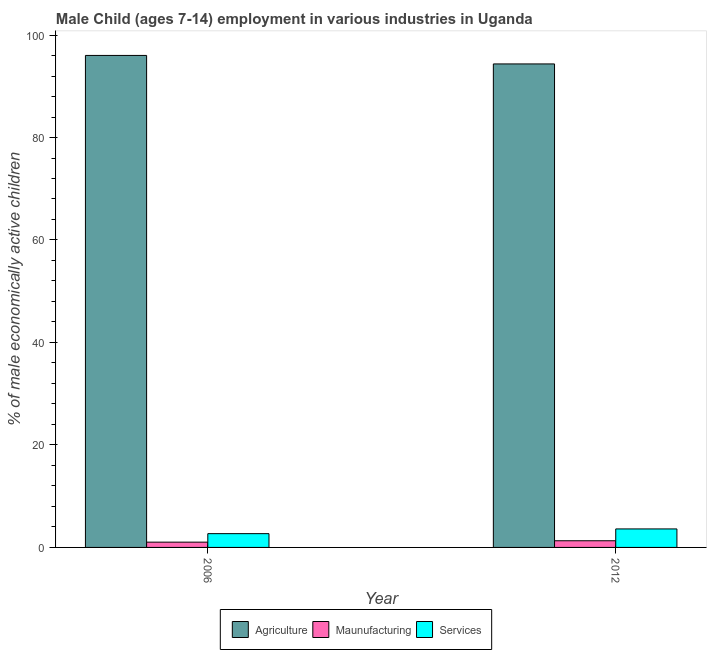How many groups of bars are there?
Offer a very short reply. 2. What is the label of the 1st group of bars from the left?
Provide a short and direct response. 2006. What is the percentage of economically active children in services in 2006?
Provide a succinct answer. 2.69. Across all years, what is the maximum percentage of economically active children in services?
Ensure brevity in your answer.  3.61. In which year was the percentage of economically active children in agriculture minimum?
Your answer should be compact. 2012. What is the total percentage of economically active children in manufacturing in the graph?
Give a very brief answer. 2.33. What is the difference between the percentage of economically active children in agriculture in 2006 and that in 2012?
Ensure brevity in your answer.  1.66. What is the difference between the percentage of economically active children in agriculture in 2006 and the percentage of economically active children in manufacturing in 2012?
Your response must be concise. 1.66. What is the average percentage of economically active children in agriculture per year?
Your answer should be very brief. 95.19. What is the ratio of the percentage of economically active children in agriculture in 2006 to that in 2012?
Your response must be concise. 1.02. What does the 3rd bar from the left in 2012 represents?
Provide a short and direct response. Services. What does the 2nd bar from the right in 2006 represents?
Your response must be concise. Maunufacturing. Is it the case that in every year, the sum of the percentage of economically active children in agriculture and percentage of economically active children in manufacturing is greater than the percentage of economically active children in services?
Make the answer very short. Yes. How many years are there in the graph?
Offer a very short reply. 2. Are the values on the major ticks of Y-axis written in scientific E-notation?
Make the answer very short. No. Where does the legend appear in the graph?
Provide a short and direct response. Bottom center. How many legend labels are there?
Provide a short and direct response. 3. What is the title of the graph?
Ensure brevity in your answer.  Male Child (ages 7-14) employment in various industries in Uganda. Does "Agricultural Nitrous Oxide" appear as one of the legend labels in the graph?
Keep it short and to the point. No. What is the label or title of the Y-axis?
Ensure brevity in your answer.  % of male economically active children. What is the % of male economically active children of Agriculture in 2006?
Offer a very short reply. 96.02. What is the % of male economically active children of Services in 2006?
Provide a succinct answer. 2.69. What is the % of male economically active children in Agriculture in 2012?
Your answer should be compact. 94.36. What is the % of male economically active children of Services in 2012?
Ensure brevity in your answer.  3.61. Across all years, what is the maximum % of male economically active children of Agriculture?
Give a very brief answer. 96.02. Across all years, what is the maximum % of male economically active children in Services?
Keep it short and to the point. 3.61. Across all years, what is the minimum % of male economically active children in Agriculture?
Keep it short and to the point. 94.36. Across all years, what is the minimum % of male economically active children in Services?
Ensure brevity in your answer.  2.69. What is the total % of male economically active children of Agriculture in the graph?
Provide a succinct answer. 190.38. What is the total % of male economically active children of Maunufacturing in the graph?
Keep it short and to the point. 2.33. What is the difference between the % of male economically active children in Agriculture in 2006 and that in 2012?
Offer a very short reply. 1.66. What is the difference between the % of male economically active children in Maunufacturing in 2006 and that in 2012?
Your response must be concise. -0.27. What is the difference between the % of male economically active children of Services in 2006 and that in 2012?
Provide a short and direct response. -0.92. What is the difference between the % of male economically active children in Agriculture in 2006 and the % of male economically active children in Maunufacturing in 2012?
Provide a succinct answer. 94.72. What is the difference between the % of male economically active children of Agriculture in 2006 and the % of male economically active children of Services in 2012?
Give a very brief answer. 92.41. What is the difference between the % of male economically active children of Maunufacturing in 2006 and the % of male economically active children of Services in 2012?
Offer a terse response. -2.58. What is the average % of male economically active children of Agriculture per year?
Your answer should be very brief. 95.19. What is the average % of male economically active children of Maunufacturing per year?
Make the answer very short. 1.17. What is the average % of male economically active children of Services per year?
Provide a succinct answer. 3.15. In the year 2006, what is the difference between the % of male economically active children in Agriculture and % of male economically active children in Maunufacturing?
Provide a succinct answer. 94.99. In the year 2006, what is the difference between the % of male economically active children in Agriculture and % of male economically active children in Services?
Ensure brevity in your answer.  93.33. In the year 2006, what is the difference between the % of male economically active children of Maunufacturing and % of male economically active children of Services?
Provide a succinct answer. -1.66. In the year 2012, what is the difference between the % of male economically active children in Agriculture and % of male economically active children in Maunufacturing?
Make the answer very short. 93.06. In the year 2012, what is the difference between the % of male economically active children of Agriculture and % of male economically active children of Services?
Your answer should be compact. 90.75. In the year 2012, what is the difference between the % of male economically active children of Maunufacturing and % of male economically active children of Services?
Provide a short and direct response. -2.31. What is the ratio of the % of male economically active children of Agriculture in 2006 to that in 2012?
Offer a very short reply. 1.02. What is the ratio of the % of male economically active children in Maunufacturing in 2006 to that in 2012?
Provide a short and direct response. 0.79. What is the ratio of the % of male economically active children of Services in 2006 to that in 2012?
Offer a terse response. 0.75. What is the difference between the highest and the second highest % of male economically active children in Agriculture?
Your answer should be compact. 1.66. What is the difference between the highest and the second highest % of male economically active children in Maunufacturing?
Your answer should be very brief. 0.27. What is the difference between the highest and the second highest % of male economically active children of Services?
Your answer should be compact. 0.92. What is the difference between the highest and the lowest % of male economically active children of Agriculture?
Your answer should be compact. 1.66. What is the difference between the highest and the lowest % of male economically active children of Maunufacturing?
Your response must be concise. 0.27. What is the difference between the highest and the lowest % of male economically active children of Services?
Make the answer very short. 0.92. 